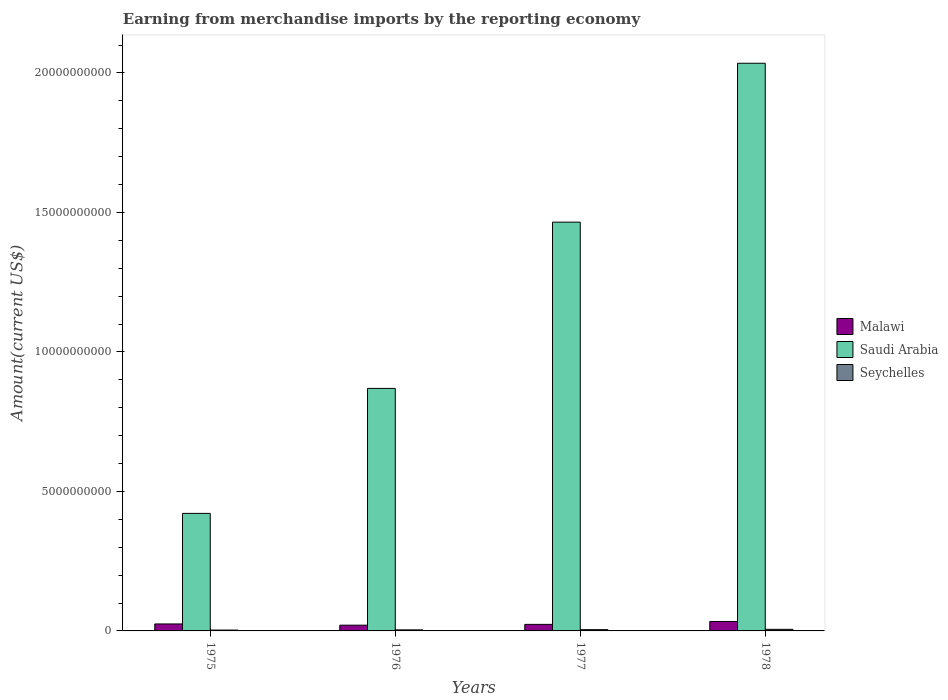Are the number of bars on each tick of the X-axis equal?
Provide a short and direct response. Yes. How many bars are there on the 3rd tick from the left?
Give a very brief answer. 3. What is the label of the 2nd group of bars from the left?
Your answer should be very brief. 1976. In how many cases, is the number of bars for a given year not equal to the number of legend labels?
Your answer should be compact. 0. What is the amount earned from merchandise imports in Malawi in 1975?
Your response must be concise. 2.50e+08. Across all years, what is the maximum amount earned from merchandise imports in Saudi Arabia?
Provide a succinct answer. 2.03e+1. Across all years, what is the minimum amount earned from merchandise imports in Saudi Arabia?
Offer a very short reply. 4.21e+09. In which year was the amount earned from merchandise imports in Saudi Arabia maximum?
Provide a short and direct response. 1978. In which year was the amount earned from merchandise imports in Malawi minimum?
Provide a short and direct response. 1976. What is the total amount earned from merchandise imports in Malawi in the graph?
Offer a terse response. 1.03e+09. What is the difference between the amount earned from merchandise imports in Seychelles in 1976 and that in 1978?
Keep it short and to the point. -1.95e+07. What is the difference between the amount earned from merchandise imports in Seychelles in 1975 and the amount earned from merchandise imports in Saudi Arabia in 1976?
Ensure brevity in your answer.  -8.66e+09. What is the average amount earned from merchandise imports in Malawi per year?
Make the answer very short. 2.57e+08. In the year 1976, what is the difference between the amount earned from merchandise imports in Saudi Arabia and amount earned from merchandise imports in Seychelles?
Your answer should be very brief. 8.66e+09. In how many years, is the amount earned from merchandise imports in Saudi Arabia greater than 15000000000 US$?
Provide a succinct answer. 1. What is the ratio of the amount earned from merchandise imports in Malawi in 1975 to that in 1976?
Offer a terse response. 1.22. Is the amount earned from merchandise imports in Malawi in 1975 less than that in 1978?
Make the answer very short. Yes. Is the difference between the amount earned from merchandise imports in Saudi Arabia in 1975 and 1978 greater than the difference between the amount earned from merchandise imports in Seychelles in 1975 and 1978?
Keep it short and to the point. No. What is the difference between the highest and the second highest amount earned from merchandise imports in Malawi?
Offer a terse response. 8.88e+07. What is the difference between the highest and the lowest amount earned from merchandise imports in Seychelles?
Provide a succinct answer. 2.68e+07. In how many years, is the amount earned from merchandise imports in Saudi Arabia greater than the average amount earned from merchandise imports in Saudi Arabia taken over all years?
Ensure brevity in your answer.  2. Is the sum of the amount earned from merchandise imports in Malawi in 1976 and 1977 greater than the maximum amount earned from merchandise imports in Seychelles across all years?
Provide a succinct answer. Yes. What does the 1st bar from the left in 1976 represents?
Keep it short and to the point. Malawi. What does the 2nd bar from the right in 1975 represents?
Keep it short and to the point. Saudi Arabia. Is it the case that in every year, the sum of the amount earned from merchandise imports in Malawi and amount earned from merchandise imports in Seychelles is greater than the amount earned from merchandise imports in Saudi Arabia?
Your answer should be compact. No. Are all the bars in the graph horizontal?
Your response must be concise. No. How many years are there in the graph?
Ensure brevity in your answer.  4. Are the values on the major ticks of Y-axis written in scientific E-notation?
Your response must be concise. No. Does the graph contain any zero values?
Provide a short and direct response. No. Where does the legend appear in the graph?
Offer a very short reply. Center right. How many legend labels are there?
Make the answer very short. 3. How are the legend labels stacked?
Offer a terse response. Vertical. What is the title of the graph?
Your response must be concise. Earning from merchandise imports by the reporting economy. Does "Slovenia" appear as one of the legend labels in the graph?
Offer a terse response. No. What is the label or title of the Y-axis?
Provide a short and direct response. Amount(current US$). What is the Amount(current US$) of Malawi in 1975?
Make the answer very short. 2.50e+08. What is the Amount(current US$) in Saudi Arabia in 1975?
Your answer should be very brief. 4.21e+09. What is the Amount(current US$) in Seychelles in 1975?
Your response must be concise. 3.03e+07. What is the Amount(current US$) of Malawi in 1976?
Your response must be concise. 2.06e+08. What is the Amount(current US$) of Saudi Arabia in 1976?
Offer a terse response. 8.69e+09. What is the Amount(current US$) of Seychelles in 1976?
Offer a terse response. 3.76e+07. What is the Amount(current US$) of Malawi in 1977?
Your response must be concise. 2.35e+08. What is the Amount(current US$) in Saudi Arabia in 1977?
Give a very brief answer. 1.47e+1. What is the Amount(current US$) in Seychelles in 1977?
Provide a short and direct response. 4.53e+07. What is the Amount(current US$) in Malawi in 1978?
Keep it short and to the point. 3.39e+08. What is the Amount(current US$) of Saudi Arabia in 1978?
Keep it short and to the point. 2.03e+1. What is the Amount(current US$) of Seychelles in 1978?
Keep it short and to the point. 5.71e+07. Across all years, what is the maximum Amount(current US$) in Malawi?
Keep it short and to the point. 3.39e+08. Across all years, what is the maximum Amount(current US$) of Saudi Arabia?
Provide a short and direct response. 2.03e+1. Across all years, what is the maximum Amount(current US$) in Seychelles?
Offer a terse response. 5.71e+07. Across all years, what is the minimum Amount(current US$) of Malawi?
Ensure brevity in your answer.  2.06e+08. Across all years, what is the minimum Amount(current US$) of Saudi Arabia?
Ensure brevity in your answer.  4.21e+09. Across all years, what is the minimum Amount(current US$) of Seychelles?
Ensure brevity in your answer.  3.03e+07. What is the total Amount(current US$) of Malawi in the graph?
Your response must be concise. 1.03e+09. What is the total Amount(current US$) in Saudi Arabia in the graph?
Provide a succinct answer. 4.79e+1. What is the total Amount(current US$) of Seychelles in the graph?
Keep it short and to the point. 1.70e+08. What is the difference between the Amount(current US$) of Malawi in 1975 and that in 1976?
Offer a very short reply. 4.43e+07. What is the difference between the Amount(current US$) in Saudi Arabia in 1975 and that in 1976?
Make the answer very short. -4.48e+09. What is the difference between the Amount(current US$) in Seychelles in 1975 and that in 1976?
Your answer should be very brief. -7.30e+06. What is the difference between the Amount(current US$) in Malawi in 1975 and that in 1977?
Offer a terse response. 1.52e+07. What is the difference between the Amount(current US$) in Saudi Arabia in 1975 and that in 1977?
Your response must be concise. -1.04e+1. What is the difference between the Amount(current US$) in Seychelles in 1975 and that in 1977?
Offer a terse response. -1.50e+07. What is the difference between the Amount(current US$) in Malawi in 1975 and that in 1978?
Your answer should be compact. -8.88e+07. What is the difference between the Amount(current US$) of Saudi Arabia in 1975 and that in 1978?
Provide a succinct answer. -1.61e+1. What is the difference between the Amount(current US$) of Seychelles in 1975 and that in 1978?
Your answer should be very brief. -2.68e+07. What is the difference between the Amount(current US$) of Malawi in 1976 and that in 1977?
Ensure brevity in your answer.  -2.91e+07. What is the difference between the Amount(current US$) of Saudi Arabia in 1976 and that in 1977?
Make the answer very short. -5.96e+09. What is the difference between the Amount(current US$) of Seychelles in 1976 and that in 1977?
Your answer should be compact. -7.70e+06. What is the difference between the Amount(current US$) of Malawi in 1976 and that in 1978?
Your answer should be very brief. -1.33e+08. What is the difference between the Amount(current US$) in Saudi Arabia in 1976 and that in 1978?
Offer a terse response. -1.17e+1. What is the difference between the Amount(current US$) in Seychelles in 1976 and that in 1978?
Your answer should be compact. -1.95e+07. What is the difference between the Amount(current US$) of Malawi in 1977 and that in 1978?
Your answer should be compact. -1.04e+08. What is the difference between the Amount(current US$) in Saudi Arabia in 1977 and that in 1978?
Ensure brevity in your answer.  -5.70e+09. What is the difference between the Amount(current US$) of Seychelles in 1977 and that in 1978?
Offer a very short reply. -1.18e+07. What is the difference between the Amount(current US$) in Malawi in 1975 and the Amount(current US$) in Saudi Arabia in 1976?
Offer a terse response. -8.44e+09. What is the difference between the Amount(current US$) of Malawi in 1975 and the Amount(current US$) of Seychelles in 1976?
Keep it short and to the point. 2.12e+08. What is the difference between the Amount(current US$) in Saudi Arabia in 1975 and the Amount(current US$) in Seychelles in 1976?
Your answer should be compact. 4.18e+09. What is the difference between the Amount(current US$) of Malawi in 1975 and the Amount(current US$) of Saudi Arabia in 1977?
Your response must be concise. -1.44e+1. What is the difference between the Amount(current US$) of Malawi in 1975 and the Amount(current US$) of Seychelles in 1977?
Your answer should be very brief. 2.05e+08. What is the difference between the Amount(current US$) in Saudi Arabia in 1975 and the Amount(current US$) in Seychelles in 1977?
Provide a succinct answer. 4.17e+09. What is the difference between the Amount(current US$) of Malawi in 1975 and the Amount(current US$) of Saudi Arabia in 1978?
Give a very brief answer. -2.01e+1. What is the difference between the Amount(current US$) in Malawi in 1975 and the Amount(current US$) in Seychelles in 1978?
Provide a short and direct response. 1.93e+08. What is the difference between the Amount(current US$) in Saudi Arabia in 1975 and the Amount(current US$) in Seychelles in 1978?
Keep it short and to the point. 4.16e+09. What is the difference between the Amount(current US$) in Malawi in 1976 and the Amount(current US$) in Saudi Arabia in 1977?
Your response must be concise. -1.44e+1. What is the difference between the Amount(current US$) of Malawi in 1976 and the Amount(current US$) of Seychelles in 1977?
Ensure brevity in your answer.  1.60e+08. What is the difference between the Amount(current US$) in Saudi Arabia in 1976 and the Amount(current US$) in Seychelles in 1977?
Your answer should be very brief. 8.65e+09. What is the difference between the Amount(current US$) of Malawi in 1976 and the Amount(current US$) of Saudi Arabia in 1978?
Keep it short and to the point. -2.01e+1. What is the difference between the Amount(current US$) in Malawi in 1976 and the Amount(current US$) in Seychelles in 1978?
Offer a very short reply. 1.49e+08. What is the difference between the Amount(current US$) of Saudi Arabia in 1976 and the Amount(current US$) of Seychelles in 1978?
Offer a terse response. 8.64e+09. What is the difference between the Amount(current US$) of Malawi in 1977 and the Amount(current US$) of Saudi Arabia in 1978?
Provide a short and direct response. -2.01e+1. What is the difference between the Amount(current US$) in Malawi in 1977 and the Amount(current US$) in Seychelles in 1978?
Offer a very short reply. 1.78e+08. What is the difference between the Amount(current US$) in Saudi Arabia in 1977 and the Amount(current US$) in Seychelles in 1978?
Your answer should be very brief. 1.46e+1. What is the average Amount(current US$) of Malawi per year?
Give a very brief answer. 2.57e+08. What is the average Amount(current US$) in Saudi Arabia per year?
Provide a succinct answer. 1.20e+1. What is the average Amount(current US$) in Seychelles per year?
Provide a succinct answer. 4.26e+07. In the year 1975, what is the difference between the Amount(current US$) in Malawi and Amount(current US$) in Saudi Arabia?
Offer a very short reply. -3.96e+09. In the year 1975, what is the difference between the Amount(current US$) in Malawi and Amount(current US$) in Seychelles?
Your answer should be compact. 2.20e+08. In the year 1975, what is the difference between the Amount(current US$) of Saudi Arabia and Amount(current US$) of Seychelles?
Ensure brevity in your answer.  4.18e+09. In the year 1976, what is the difference between the Amount(current US$) in Malawi and Amount(current US$) in Saudi Arabia?
Make the answer very short. -8.49e+09. In the year 1976, what is the difference between the Amount(current US$) of Malawi and Amount(current US$) of Seychelles?
Keep it short and to the point. 1.68e+08. In the year 1976, what is the difference between the Amount(current US$) in Saudi Arabia and Amount(current US$) in Seychelles?
Your response must be concise. 8.66e+09. In the year 1977, what is the difference between the Amount(current US$) of Malawi and Amount(current US$) of Saudi Arabia?
Give a very brief answer. -1.44e+1. In the year 1977, what is the difference between the Amount(current US$) of Malawi and Amount(current US$) of Seychelles?
Your response must be concise. 1.90e+08. In the year 1977, what is the difference between the Amount(current US$) of Saudi Arabia and Amount(current US$) of Seychelles?
Provide a succinct answer. 1.46e+1. In the year 1978, what is the difference between the Amount(current US$) in Malawi and Amount(current US$) in Saudi Arabia?
Keep it short and to the point. -2.00e+1. In the year 1978, what is the difference between the Amount(current US$) of Malawi and Amount(current US$) of Seychelles?
Offer a very short reply. 2.82e+08. In the year 1978, what is the difference between the Amount(current US$) of Saudi Arabia and Amount(current US$) of Seychelles?
Keep it short and to the point. 2.03e+1. What is the ratio of the Amount(current US$) in Malawi in 1975 to that in 1976?
Ensure brevity in your answer.  1.22. What is the ratio of the Amount(current US$) of Saudi Arabia in 1975 to that in 1976?
Your answer should be compact. 0.48. What is the ratio of the Amount(current US$) of Seychelles in 1975 to that in 1976?
Offer a terse response. 0.81. What is the ratio of the Amount(current US$) in Malawi in 1975 to that in 1977?
Ensure brevity in your answer.  1.06. What is the ratio of the Amount(current US$) in Saudi Arabia in 1975 to that in 1977?
Ensure brevity in your answer.  0.29. What is the ratio of the Amount(current US$) in Seychelles in 1975 to that in 1977?
Ensure brevity in your answer.  0.67. What is the ratio of the Amount(current US$) of Malawi in 1975 to that in 1978?
Make the answer very short. 0.74. What is the ratio of the Amount(current US$) of Saudi Arabia in 1975 to that in 1978?
Your response must be concise. 0.21. What is the ratio of the Amount(current US$) in Seychelles in 1975 to that in 1978?
Your response must be concise. 0.53. What is the ratio of the Amount(current US$) in Malawi in 1976 to that in 1977?
Ensure brevity in your answer.  0.88. What is the ratio of the Amount(current US$) of Saudi Arabia in 1976 to that in 1977?
Offer a very short reply. 0.59. What is the ratio of the Amount(current US$) of Seychelles in 1976 to that in 1977?
Your response must be concise. 0.83. What is the ratio of the Amount(current US$) in Malawi in 1976 to that in 1978?
Provide a succinct answer. 0.61. What is the ratio of the Amount(current US$) of Saudi Arabia in 1976 to that in 1978?
Offer a terse response. 0.43. What is the ratio of the Amount(current US$) in Seychelles in 1976 to that in 1978?
Provide a short and direct response. 0.66. What is the ratio of the Amount(current US$) in Malawi in 1977 to that in 1978?
Ensure brevity in your answer.  0.69. What is the ratio of the Amount(current US$) of Saudi Arabia in 1977 to that in 1978?
Ensure brevity in your answer.  0.72. What is the ratio of the Amount(current US$) in Seychelles in 1977 to that in 1978?
Ensure brevity in your answer.  0.79. What is the difference between the highest and the second highest Amount(current US$) of Malawi?
Offer a very short reply. 8.88e+07. What is the difference between the highest and the second highest Amount(current US$) in Saudi Arabia?
Make the answer very short. 5.70e+09. What is the difference between the highest and the second highest Amount(current US$) of Seychelles?
Offer a very short reply. 1.18e+07. What is the difference between the highest and the lowest Amount(current US$) in Malawi?
Your response must be concise. 1.33e+08. What is the difference between the highest and the lowest Amount(current US$) in Saudi Arabia?
Provide a succinct answer. 1.61e+1. What is the difference between the highest and the lowest Amount(current US$) of Seychelles?
Your answer should be compact. 2.68e+07. 